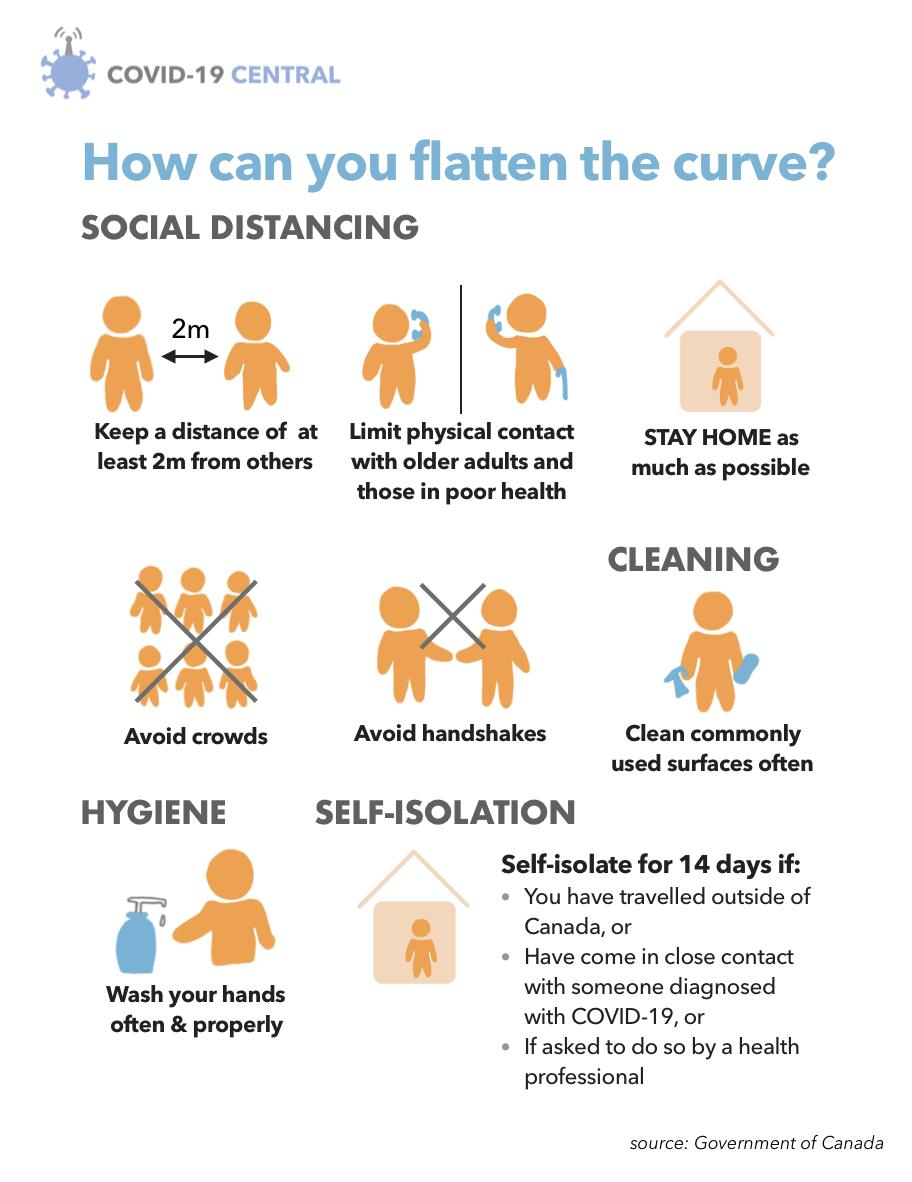Identify some key points in this picture. The infographic image contains two do nots. To effectively control the spread of COVID-19, it is crucial to avoid crowds and avoid physical contact, particularly handshakes. To self-isolate, there have been highlighted three reasons. It is recommended to maintain a minimum safe distance of 2 meters from others in order to control the spread of COVID-19 virus. 